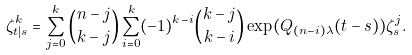<formula> <loc_0><loc_0><loc_500><loc_500>\zeta ^ { k } _ { t | s } = \sum _ { j = 0 } ^ { k } { n - j \choose k - j } \sum _ { i = 0 } ^ { k } ( - 1 ) ^ { k - i } { k - j \choose k - i } \exp ( Q _ { ( n - i ) \lambda } ( t - s ) ) \zeta ^ { j } _ { s } .</formula> 